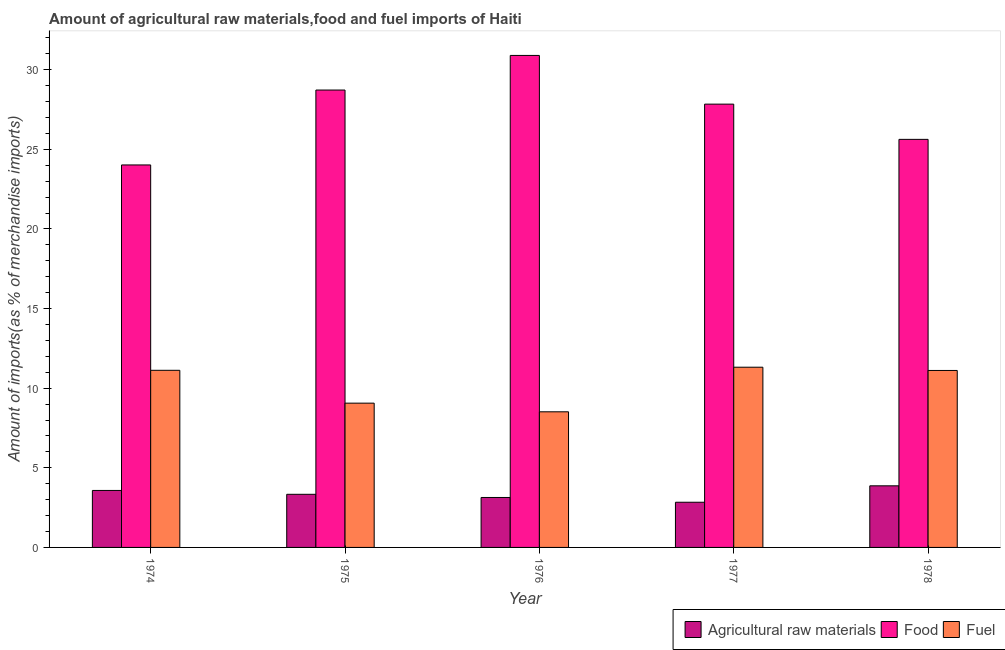Are the number of bars per tick equal to the number of legend labels?
Your response must be concise. Yes. How many bars are there on the 3rd tick from the left?
Offer a terse response. 3. How many bars are there on the 3rd tick from the right?
Your response must be concise. 3. What is the label of the 2nd group of bars from the left?
Offer a very short reply. 1975. In how many cases, is the number of bars for a given year not equal to the number of legend labels?
Provide a succinct answer. 0. What is the percentage of fuel imports in 1977?
Your response must be concise. 11.32. Across all years, what is the maximum percentage of food imports?
Your answer should be compact. 30.9. Across all years, what is the minimum percentage of raw materials imports?
Offer a terse response. 2.84. In which year was the percentage of fuel imports maximum?
Ensure brevity in your answer.  1977. In which year was the percentage of food imports minimum?
Make the answer very short. 1974. What is the total percentage of fuel imports in the graph?
Your answer should be compact. 51.13. What is the difference between the percentage of raw materials imports in 1977 and that in 1978?
Your answer should be very brief. -1.03. What is the difference between the percentage of raw materials imports in 1978 and the percentage of fuel imports in 1974?
Your answer should be very brief. 0.29. What is the average percentage of food imports per year?
Offer a very short reply. 27.42. What is the ratio of the percentage of raw materials imports in 1974 to that in 1978?
Your answer should be compact. 0.92. Is the percentage of fuel imports in 1976 less than that in 1977?
Ensure brevity in your answer.  Yes. Is the difference between the percentage of fuel imports in 1976 and 1977 greater than the difference between the percentage of food imports in 1976 and 1977?
Keep it short and to the point. No. What is the difference between the highest and the second highest percentage of fuel imports?
Your answer should be compact. 0.19. What is the difference between the highest and the lowest percentage of food imports?
Provide a succinct answer. 6.88. Is the sum of the percentage of raw materials imports in 1977 and 1978 greater than the maximum percentage of food imports across all years?
Provide a succinct answer. Yes. What does the 1st bar from the left in 1976 represents?
Keep it short and to the point. Agricultural raw materials. What does the 3rd bar from the right in 1978 represents?
Keep it short and to the point. Agricultural raw materials. Is it the case that in every year, the sum of the percentage of raw materials imports and percentage of food imports is greater than the percentage of fuel imports?
Your answer should be very brief. Yes. Are all the bars in the graph horizontal?
Keep it short and to the point. No. Does the graph contain any zero values?
Provide a short and direct response. No. Does the graph contain grids?
Give a very brief answer. No. Where does the legend appear in the graph?
Provide a succinct answer. Bottom right. How many legend labels are there?
Your answer should be compact. 3. What is the title of the graph?
Provide a short and direct response. Amount of agricultural raw materials,food and fuel imports of Haiti. Does "Communicable diseases" appear as one of the legend labels in the graph?
Give a very brief answer. No. What is the label or title of the X-axis?
Provide a short and direct response. Year. What is the label or title of the Y-axis?
Provide a succinct answer. Amount of imports(as % of merchandise imports). What is the Amount of imports(as % of merchandise imports) of Agricultural raw materials in 1974?
Keep it short and to the point. 3.58. What is the Amount of imports(as % of merchandise imports) of Food in 1974?
Keep it short and to the point. 24.02. What is the Amount of imports(as % of merchandise imports) of Fuel in 1974?
Provide a short and direct response. 11.12. What is the Amount of imports(as % of merchandise imports) in Agricultural raw materials in 1975?
Give a very brief answer. 3.34. What is the Amount of imports(as % of merchandise imports) in Food in 1975?
Your answer should be compact. 28.72. What is the Amount of imports(as % of merchandise imports) in Fuel in 1975?
Provide a succinct answer. 9.06. What is the Amount of imports(as % of merchandise imports) of Agricultural raw materials in 1976?
Make the answer very short. 3.14. What is the Amount of imports(as % of merchandise imports) in Food in 1976?
Provide a short and direct response. 30.9. What is the Amount of imports(as % of merchandise imports) of Fuel in 1976?
Provide a short and direct response. 8.52. What is the Amount of imports(as % of merchandise imports) of Agricultural raw materials in 1977?
Make the answer very short. 2.84. What is the Amount of imports(as % of merchandise imports) in Food in 1977?
Your answer should be very brief. 27.84. What is the Amount of imports(as % of merchandise imports) in Fuel in 1977?
Provide a short and direct response. 11.32. What is the Amount of imports(as % of merchandise imports) in Agricultural raw materials in 1978?
Your answer should be compact. 3.87. What is the Amount of imports(as % of merchandise imports) in Food in 1978?
Your answer should be very brief. 25.63. What is the Amount of imports(as % of merchandise imports) in Fuel in 1978?
Make the answer very short. 11.11. Across all years, what is the maximum Amount of imports(as % of merchandise imports) in Agricultural raw materials?
Ensure brevity in your answer.  3.87. Across all years, what is the maximum Amount of imports(as % of merchandise imports) of Food?
Provide a short and direct response. 30.9. Across all years, what is the maximum Amount of imports(as % of merchandise imports) in Fuel?
Make the answer very short. 11.32. Across all years, what is the minimum Amount of imports(as % of merchandise imports) in Agricultural raw materials?
Make the answer very short. 2.84. Across all years, what is the minimum Amount of imports(as % of merchandise imports) in Food?
Your answer should be compact. 24.02. Across all years, what is the minimum Amount of imports(as % of merchandise imports) of Fuel?
Your response must be concise. 8.52. What is the total Amount of imports(as % of merchandise imports) in Agricultural raw materials in the graph?
Keep it short and to the point. 16.76. What is the total Amount of imports(as % of merchandise imports) in Food in the graph?
Your answer should be compact. 137.1. What is the total Amount of imports(as % of merchandise imports) of Fuel in the graph?
Your answer should be very brief. 51.13. What is the difference between the Amount of imports(as % of merchandise imports) of Agricultural raw materials in 1974 and that in 1975?
Make the answer very short. 0.24. What is the difference between the Amount of imports(as % of merchandise imports) in Food in 1974 and that in 1975?
Ensure brevity in your answer.  -4.7. What is the difference between the Amount of imports(as % of merchandise imports) of Fuel in 1974 and that in 1975?
Offer a very short reply. 2.06. What is the difference between the Amount of imports(as % of merchandise imports) in Agricultural raw materials in 1974 and that in 1976?
Provide a short and direct response. 0.44. What is the difference between the Amount of imports(as % of merchandise imports) of Food in 1974 and that in 1976?
Your response must be concise. -6.88. What is the difference between the Amount of imports(as % of merchandise imports) of Fuel in 1974 and that in 1976?
Offer a terse response. 2.61. What is the difference between the Amount of imports(as % of merchandise imports) in Agricultural raw materials in 1974 and that in 1977?
Ensure brevity in your answer.  0.74. What is the difference between the Amount of imports(as % of merchandise imports) of Food in 1974 and that in 1977?
Your response must be concise. -3.82. What is the difference between the Amount of imports(as % of merchandise imports) in Fuel in 1974 and that in 1977?
Ensure brevity in your answer.  -0.2. What is the difference between the Amount of imports(as % of merchandise imports) of Agricultural raw materials in 1974 and that in 1978?
Ensure brevity in your answer.  -0.29. What is the difference between the Amount of imports(as % of merchandise imports) in Food in 1974 and that in 1978?
Give a very brief answer. -1.61. What is the difference between the Amount of imports(as % of merchandise imports) in Fuel in 1974 and that in 1978?
Offer a terse response. 0.01. What is the difference between the Amount of imports(as % of merchandise imports) of Agricultural raw materials in 1975 and that in 1976?
Your response must be concise. 0.2. What is the difference between the Amount of imports(as % of merchandise imports) in Food in 1975 and that in 1976?
Offer a very short reply. -2.17. What is the difference between the Amount of imports(as % of merchandise imports) in Fuel in 1975 and that in 1976?
Give a very brief answer. 0.54. What is the difference between the Amount of imports(as % of merchandise imports) in Agricultural raw materials in 1975 and that in 1977?
Make the answer very short. 0.5. What is the difference between the Amount of imports(as % of merchandise imports) of Food in 1975 and that in 1977?
Provide a succinct answer. 0.88. What is the difference between the Amount of imports(as % of merchandise imports) in Fuel in 1975 and that in 1977?
Make the answer very short. -2.26. What is the difference between the Amount of imports(as % of merchandise imports) in Agricultural raw materials in 1975 and that in 1978?
Your answer should be very brief. -0.53. What is the difference between the Amount of imports(as % of merchandise imports) in Food in 1975 and that in 1978?
Your answer should be very brief. 3.1. What is the difference between the Amount of imports(as % of merchandise imports) in Fuel in 1975 and that in 1978?
Your response must be concise. -2.05. What is the difference between the Amount of imports(as % of merchandise imports) in Agricultural raw materials in 1976 and that in 1977?
Ensure brevity in your answer.  0.3. What is the difference between the Amount of imports(as % of merchandise imports) in Food in 1976 and that in 1977?
Ensure brevity in your answer.  3.06. What is the difference between the Amount of imports(as % of merchandise imports) in Fuel in 1976 and that in 1977?
Keep it short and to the point. -2.8. What is the difference between the Amount of imports(as % of merchandise imports) in Agricultural raw materials in 1976 and that in 1978?
Offer a terse response. -0.73. What is the difference between the Amount of imports(as % of merchandise imports) in Food in 1976 and that in 1978?
Ensure brevity in your answer.  5.27. What is the difference between the Amount of imports(as % of merchandise imports) of Fuel in 1976 and that in 1978?
Ensure brevity in your answer.  -2.6. What is the difference between the Amount of imports(as % of merchandise imports) of Agricultural raw materials in 1977 and that in 1978?
Your answer should be compact. -1.03. What is the difference between the Amount of imports(as % of merchandise imports) of Food in 1977 and that in 1978?
Provide a succinct answer. 2.21. What is the difference between the Amount of imports(as % of merchandise imports) of Fuel in 1977 and that in 1978?
Offer a very short reply. 0.2. What is the difference between the Amount of imports(as % of merchandise imports) of Agricultural raw materials in 1974 and the Amount of imports(as % of merchandise imports) of Food in 1975?
Your response must be concise. -25.14. What is the difference between the Amount of imports(as % of merchandise imports) in Agricultural raw materials in 1974 and the Amount of imports(as % of merchandise imports) in Fuel in 1975?
Ensure brevity in your answer.  -5.48. What is the difference between the Amount of imports(as % of merchandise imports) of Food in 1974 and the Amount of imports(as % of merchandise imports) of Fuel in 1975?
Your answer should be very brief. 14.96. What is the difference between the Amount of imports(as % of merchandise imports) of Agricultural raw materials in 1974 and the Amount of imports(as % of merchandise imports) of Food in 1976?
Your response must be concise. -27.32. What is the difference between the Amount of imports(as % of merchandise imports) in Agricultural raw materials in 1974 and the Amount of imports(as % of merchandise imports) in Fuel in 1976?
Your response must be concise. -4.94. What is the difference between the Amount of imports(as % of merchandise imports) in Food in 1974 and the Amount of imports(as % of merchandise imports) in Fuel in 1976?
Provide a succinct answer. 15.5. What is the difference between the Amount of imports(as % of merchandise imports) of Agricultural raw materials in 1974 and the Amount of imports(as % of merchandise imports) of Food in 1977?
Provide a short and direct response. -24.26. What is the difference between the Amount of imports(as % of merchandise imports) in Agricultural raw materials in 1974 and the Amount of imports(as % of merchandise imports) in Fuel in 1977?
Provide a short and direct response. -7.74. What is the difference between the Amount of imports(as % of merchandise imports) of Food in 1974 and the Amount of imports(as % of merchandise imports) of Fuel in 1977?
Offer a terse response. 12.7. What is the difference between the Amount of imports(as % of merchandise imports) of Agricultural raw materials in 1974 and the Amount of imports(as % of merchandise imports) of Food in 1978?
Offer a very short reply. -22.05. What is the difference between the Amount of imports(as % of merchandise imports) of Agricultural raw materials in 1974 and the Amount of imports(as % of merchandise imports) of Fuel in 1978?
Your answer should be compact. -7.54. What is the difference between the Amount of imports(as % of merchandise imports) in Food in 1974 and the Amount of imports(as % of merchandise imports) in Fuel in 1978?
Offer a very short reply. 12.91. What is the difference between the Amount of imports(as % of merchandise imports) of Agricultural raw materials in 1975 and the Amount of imports(as % of merchandise imports) of Food in 1976?
Offer a terse response. -27.56. What is the difference between the Amount of imports(as % of merchandise imports) of Agricultural raw materials in 1975 and the Amount of imports(as % of merchandise imports) of Fuel in 1976?
Provide a succinct answer. -5.18. What is the difference between the Amount of imports(as % of merchandise imports) in Food in 1975 and the Amount of imports(as % of merchandise imports) in Fuel in 1976?
Offer a terse response. 20.21. What is the difference between the Amount of imports(as % of merchandise imports) of Agricultural raw materials in 1975 and the Amount of imports(as % of merchandise imports) of Food in 1977?
Your response must be concise. -24.5. What is the difference between the Amount of imports(as % of merchandise imports) of Agricultural raw materials in 1975 and the Amount of imports(as % of merchandise imports) of Fuel in 1977?
Make the answer very short. -7.98. What is the difference between the Amount of imports(as % of merchandise imports) of Food in 1975 and the Amount of imports(as % of merchandise imports) of Fuel in 1977?
Provide a short and direct response. 17.41. What is the difference between the Amount of imports(as % of merchandise imports) in Agricultural raw materials in 1975 and the Amount of imports(as % of merchandise imports) in Food in 1978?
Your answer should be very brief. -22.29. What is the difference between the Amount of imports(as % of merchandise imports) in Agricultural raw materials in 1975 and the Amount of imports(as % of merchandise imports) in Fuel in 1978?
Your answer should be compact. -7.78. What is the difference between the Amount of imports(as % of merchandise imports) in Food in 1975 and the Amount of imports(as % of merchandise imports) in Fuel in 1978?
Make the answer very short. 17.61. What is the difference between the Amount of imports(as % of merchandise imports) of Agricultural raw materials in 1976 and the Amount of imports(as % of merchandise imports) of Food in 1977?
Offer a very short reply. -24.7. What is the difference between the Amount of imports(as % of merchandise imports) in Agricultural raw materials in 1976 and the Amount of imports(as % of merchandise imports) in Fuel in 1977?
Offer a terse response. -8.18. What is the difference between the Amount of imports(as % of merchandise imports) of Food in 1976 and the Amount of imports(as % of merchandise imports) of Fuel in 1977?
Give a very brief answer. 19.58. What is the difference between the Amount of imports(as % of merchandise imports) of Agricultural raw materials in 1976 and the Amount of imports(as % of merchandise imports) of Food in 1978?
Ensure brevity in your answer.  -22.49. What is the difference between the Amount of imports(as % of merchandise imports) in Agricultural raw materials in 1976 and the Amount of imports(as % of merchandise imports) in Fuel in 1978?
Provide a short and direct response. -7.98. What is the difference between the Amount of imports(as % of merchandise imports) in Food in 1976 and the Amount of imports(as % of merchandise imports) in Fuel in 1978?
Your answer should be compact. 19.78. What is the difference between the Amount of imports(as % of merchandise imports) in Agricultural raw materials in 1977 and the Amount of imports(as % of merchandise imports) in Food in 1978?
Offer a terse response. -22.79. What is the difference between the Amount of imports(as % of merchandise imports) in Agricultural raw materials in 1977 and the Amount of imports(as % of merchandise imports) in Fuel in 1978?
Your answer should be compact. -8.28. What is the difference between the Amount of imports(as % of merchandise imports) of Food in 1977 and the Amount of imports(as % of merchandise imports) of Fuel in 1978?
Ensure brevity in your answer.  16.73. What is the average Amount of imports(as % of merchandise imports) in Agricultural raw materials per year?
Keep it short and to the point. 3.35. What is the average Amount of imports(as % of merchandise imports) of Food per year?
Provide a succinct answer. 27.42. What is the average Amount of imports(as % of merchandise imports) of Fuel per year?
Your answer should be very brief. 10.23. In the year 1974, what is the difference between the Amount of imports(as % of merchandise imports) of Agricultural raw materials and Amount of imports(as % of merchandise imports) of Food?
Your answer should be compact. -20.44. In the year 1974, what is the difference between the Amount of imports(as % of merchandise imports) of Agricultural raw materials and Amount of imports(as % of merchandise imports) of Fuel?
Offer a terse response. -7.54. In the year 1974, what is the difference between the Amount of imports(as % of merchandise imports) in Food and Amount of imports(as % of merchandise imports) in Fuel?
Keep it short and to the point. 12.9. In the year 1975, what is the difference between the Amount of imports(as % of merchandise imports) of Agricultural raw materials and Amount of imports(as % of merchandise imports) of Food?
Ensure brevity in your answer.  -25.39. In the year 1975, what is the difference between the Amount of imports(as % of merchandise imports) of Agricultural raw materials and Amount of imports(as % of merchandise imports) of Fuel?
Your answer should be very brief. -5.72. In the year 1975, what is the difference between the Amount of imports(as % of merchandise imports) in Food and Amount of imports(as % of merchandise imports) in Fuel?
Provide a succinct answer. 19.66. In the year 1976, what is the difference between the Amount of imports(as % of merchandise imports) in Agricultural raw materials and Amount of imports(as % of merchandise imports) in Food?
Offer a very short reply. -27.76. In the year 1976, what is the difference between the Amount of imports(as % of merchandise imports) of Agricultural raw materials and Amount of imports(as % of merchandise imports) of Fuel?
Offer a terse response. -5.38. In the year 1976, what is the difference between the Amount of imports(as % of merchandise imports) in Food and Amount of imports(as % of merchandise imports) in Fuel?
Your answer should be compact. 22.38. In the year 1977, what is the difference between the Amount of imports(as % of merchandise imports) of Agricultural raw materials and Amount of imports(as % of merchandise imports) of Food?
Offer a terse response. -25. In the year 1977, what is the difference between the Amount of imports(as % of merchandise imports) in Agricultural raw materials and Amount of imports(as % of merchandise imports) in Fuel?
Your answer should be very brief. -8.48. In the year 1977, what is the difference between the Amount of imports(as % of merchandise imports) of Food and Amount of imports(as % of merchandise imports) of Fuel?
Provide a succinct answer. 16.52. In the year 1978, what is the difference between the Amount of imports(as % of merchandise imports) of Agricultural raw materials and Amount of imports(as % of merchandise imports) of Food?
Give a very brief answer. -21.76. In the year 1978, what is the difference between the Amount of imports(as % of merchandise imports) in Agricultural raw materials and Amount of imports(as % of merchandise imports) in Fuel?
Offer a very short reply. -7.24. In the year 1978, what is the difference between the Amount of imports(as % of merchandise imports) of Food and Amount of imports(as % of merchandise imports) of Fuel?
Your answer should be compact. 14.51. What is the ratio of the Amount of imports(as % of merchandise imports) in Agricultural raw materials in 1974 to that in 1975?
Offer a terse response. 1.07. What is the ratio of the Amount of imports(as % of merchandise imports) in Food in 1974 to that in 1975?
Your answer should be very brief. 0.84. What is the ratio of the Amount of imports(as % of merchandise imports) of Fuel in 1974 to that in 1975?
Make the answer very short. 1.23. What is the ratio of the Amount of imports(as % of merchandise imports) of Agricultural raw materials in 1974 to that in 1976?
Make the answer very short. 1.14. What is the ratio of the Amount of imports(as % of merchandise imports) in Food in 1974 to that in 1976?
Your answer should be compact. 0.78. What is the ratio of the Amount of imports(as % of merchandise imports) in Fuel in 1974 to that in 1976?
Provide a succinct answer. 1.31. What is the ratio of the Amount of imports(as % of merchandise imports) in Agricultural raw materials in 1974 to that in 1977?
Offer a very short reply. 1.26. What is the ratio of the Amount of imports(as % of merchandise imports) of Food in 1974 to that in 1977?
Your answer should be very brief. 0.86. What is the ratio of the Amount of imports(as % of merchandise imports) of Fuel in 1974 to that in 1977?
Your answer should be very brief. 0.98. What is the ratio of the Amount of imports(as % of merchandise imports) in Agricultural raw materials in 1974 to that in 1978?
Offer a terse response. 0.92. What is the ratio of the Amount of imports(as % of merchandise imports) of Food in 1974 to that in 1978?
Ensure brevity in your answer.  0.94. What is the ratio of the Amount of imports(as % of merchandise imports) of Agricultural raw materials in 1975 to that in 1976?
Ensure brevity in your answer.  1.06. What is the ratio of the Amount of imports(as % of merchandise imports) of Food in 1975 to that in 1976?
Provide a short and direct response. 0.93. What is the ratio of the Amount of imports(as % of merchandise imports) in Fuel in 1975 to that in 1976?
Your response must be concise. 1.06. What is the ratio of the Amount of imports(as % of merchandise imports) in Agricultural raw materials in 1975 to that in 1977?
Your response must be concise. 1.18. What is the ratio of the Amount of imports(as % of merchandise imports) of Food in 1975 to that in 1977?
Your response must be concise. 1.03. What is the ratio of the Amount of imports(as % of merchandise imports) of Fuel in 1975 to that in 1977?
Your answer should be very brief. 0.8. What is the ratio of the Amount of imports(as % of merchandise imports) of Agricultural raw materials in 1975 to that in 1978?
Your answer should be very brief. 0.86. What is the ratio of the Amount of imports(as % of merchandise imports) in Food in 1975 to that in 1978?
Your answer should be compact. 1.12. What is the ratio of the Amount of imports(as % of merchandise imports) of Fuel in 1975 to that in 1978?
Keep it short and to the point. 0.82. What is the ratio of the Amount of imports(as % of merchandise imports) of Agricultural raw materials in 1976 to that in 1977?
Offer a terse response. 1.11. What is the ratio of the Amount of imports(as % of merchandise imports) of Food in 1976 to that in 1977?
Provide a succinct answer. 1.11. What is the ratio of the Amount of imports(as % of merchandise imports) in Fuel in 1976 to that in 1977?
Offer a very short reply. 0.75. What is the ratio of the Amount of imports(as % of merchandise imports) in Agricultural raw materials in 1976 to that in 1978?
Keep it short and to the point. 0.81. What is the ratio of the Amount of imports(as % of merchandise imports) in Food in 1976 to that in 1978?
Offer a terse response. 1.21. What is the ratio of the Amount of imports(as % of merchandise imports) in Fuel in 1976 to that in 1978?
Keep it short and to the point. 0.77. What is the ratio of the Amount of imports(as % of merchandise imports) in Agricultural raw materials in 1977 to that in 1978?
Your answer should be compact. 0.73. What is the ratio of the Amount of imports(as % of merchandise imports) of Food in 1977 to that in 1978?
Make the answer very short. 1.09. What is the ratio of the Amount of imports(as % of merchandise imports) in Fuel in 1977 to that in 1978?
Your response must be concise. 1.02. What is the difference between the highest and the second highest Amount of imports(as % of merchandise imports) in Agricultural raw materials?
Provide a short and direct response. 0.29. What is the difference between the highest and the second highest Amount of imports(as % of merchandise imports) of Food?
Keep it short and to the point. 2.17. What is the difference between the highest and the second highest Amount of imports(as % of merchandise imports) in Fuel?
Your answer should be compact. 0.2. What is the difference between the highest and the lowest Amount of imports(as % of merchandise imports) in Agricultural raw materials?
Your response must be concise. 1.03. What is the difference between the highest and the lowest Amount of imports(as % of merchandise imports) in Food?
Your answer should be very brief. 6.88. What is the difference between the highest and the lowest Amount of imports(as % of merchandise imports) of Fuel?
Give a very brief answer. 2.8. 